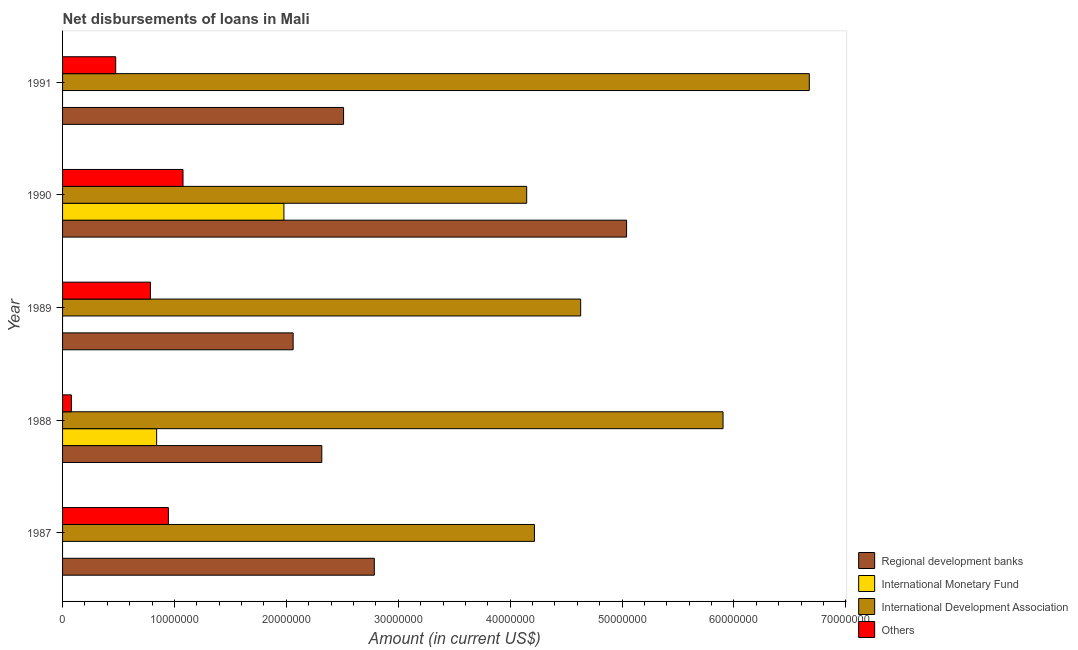Are the number of bars on each tick of the Y-axis equal?
Your response must be concise. No. How many bars are there on the 4th tick from the bottom?
Your answer should be compact. 4. What is the label of the 5th group of bars from the top?
Ensure brevity in your answer.  1987. In how many cases, is the number of bars for a given year not equal to the number of legend labels?
Your answer should be very brief. 3. What is the amount of loan disimbursed by regional development banks in 1991?
Ensure brevity in your answer.  2.51e+07. Across all years, what is the maximum amount of loan disimbursed by regional development banks?
Give a very brief answer. 5.04e+07. Across all years, what is the minimum amount of loan disimbursed by international monetary fund?
Give a very brief answer. 0. What is the total amount of loan disimbursed by international monetary fund in the graph?
Give a very brief answer. 2.82e+07. What is the difference between the amount of loan disimbursed by regional development banks in 1987 and that in 1991?
Your response must be concise. 2.75e+06. What is the difference between the amount of loan disimbursed by international monetary fund in 1989 and the amount of loan disimbursed by international development association in 1991?
Give a very brief answer. -6.67e+07. What is the average amount of loan disimbursed by other organisations per year?
Offer a terse response. 6.72e+06. In the year 1990, what is the difference between the amount of loan disimbursed by other organisations and amount of loan disimbursed by international development association?
Offer a terse response. -3.07e+07. In how many years, is the amount of loan disimbursed by international monetary fund greater than 50000000 US$?
Your answer should be compact. 0. What is the ratio of the amount of loan disimbursed by other organisations in 1988 to that in 1990?
Keep it short and to the point. 0.07. Is the difference between the amount of loan disimbursed by regional development banks in 1987 and 1991 greater than the difference between the amount of loan disimbursed by other organisations in 1987 and 1991?
Ensure brevity in your answer.  No. What is the difference between the highest and the second highest amount of loan disimbursed by regional development banks?
Offer a terse response. 2.25e+07. What is the difference between the highest and the lowest amount of loan disimbursed by other organisations?
Ensure brevity in your answer.  9.98e+06. Is the sum of the amount of loan disimbursed by international monetary fund in 1988 and 1990 greater than the maximum amount of loan disimbursed by other organisations across all years?
Your response must be concise. Yes. Are all the bars in the graph horizontal?
Provide a short and direct response. Yes. Where does the legend appear in the graph?
Offer a very short reply. Bottom right. What is the title of the graph?
Offer a very short reply. Net disbursements of loans in Mali. Does "United States" appear as one of the legend labels in the graph?
Your answer should be compact. No. What is the label or title of the Y-axis?
Offer a terse response. Year. What is the Amount (in current US$) in Regional development banks in 1987?
Ensure brevity in your answer.  2.79e+07. What is the Amount (in current US$) of International Monetary Fund in 1987?
Your response must be concise. 0. What is the Amount (in current US$) in International Development Association in 1987?
Your answer should be very brief. 4.22e+07. What is the Amount (in current US$) of Others in 1987?
Keep it short and to the point. 9.46e+06. What is the Amount (in current US$) of Regional development banks in 1988?
Ensure brevity in your answer.  2.32e+07. What is the Amount (in current US$) in International Monetary Fund in 1988?
Ensure brevity in your answer.  8.41e+06. What is the Amount (in current US$) of International Development Association in 1988?
Your answer should be very brief. 5.90e+07. What is the Amount (in current US$) of Others in 1988?
Your response must be concise. 7.87e+05. What is the Amount (in current US$) of Regional development banks in 1989?
Give a very brief answer. 2.06e+07. What is the Amount (in current US$) in International Development Association in 1989?
Make the answer very short. 4.63e+07. What is the Amount (in current US$) of Others in 1989?
Ensure brevity in your answer.  7.86e+06. What is the Amount (in current US$) in Regional development banks in 1990?
Provide a succinct answer. 5.04e+07. What is the Amount (in current US$) of International Monetary Fund in 1990?
Offer a terse response. 1.98e+07. What is the Amount (in current US$) of International Development Association in 1990?
Provide a short and direct response. 4.15e+07. What is the Amount (in current US$) of Others in 1990?
Provide a succinct answer. 1.08e+07. What is the Amount (in current US$) of Regional development banks in 1991?
Ensure brevity in your answer.  2.51e+07. What is the Amount (in current US$) in International Monetary Fund in 1991?
Offer a very short reply. 0. What is the Amount (in current US$) in International Development Association in 1991?
Offer a very short reply. 6.67e+07. What is the Amount (in current US$) of Others in 1991?
Keep it short and to the point. 4.75e+06. Across all years, what is the maximum Amount (in current US$) of Regional development banks?
Keep it short and to the point. 5.04e+07. Across all years, what is the maximum Amount (in current US$) in International Monetary Fund?
Offer a very short reply. 1.98e+07. Across all years, what is the maximum Amount (in current US$) in International Development Association?
Your response must be concise. 6.67e+07. Across all years, what is the maximum Amount (in current US$) in Others?
Make the answer very short. 1.08e+07. Across all years, what is the minimum Amount (in current US$) of Regional development banks?
Your response must be concise. 2.06e+07. Across all years, what is the minimum Amount (in current US$) in International Monetary Fund?
Give a very brief answer. 0. Across all years, what is the minimum Amount (in current US$) in International Development Association?
Offer a very short reply. 4.15e+07. Across all years, what is the minimum Amount (in current US$) in Others?
Ensure brevity in your answer.  7.87e+05. What is the total Amount (in current US$) in Regional development banks in the graph?
Ensure brevity in your answer.  1.47e+08. What is the total Amount (in current US$) in International Monetary Fund in the graph?
Offer a very short reply. 2.82e+07. What is the total Amount (in current US$) in International Development Association in the graph?
Your answer should be compact. 2.56e+08. What is the total Amount (in current US$) in Others in the graph?
Your answer should be very brief. 3.36e+07. What is the difference between the Amount (in current US$) in Regional development banks in 1987 and that in 1988?
Offer a terse response. 4.69e+06. What is the difference between the Amount (in current US$) in International Development Association in 1987 and that in 1988?
Your answer should be compact. -1.69e+07. What is the difference between the Amount (in current US$) in Others in 1987 and that in 1988?
Ensure brevity in your answer.  8.67e+06. What is the difference between the Amount (in current US$) of Regional development banks in 1987 and that in 1989?
Keep it short and to the point. 7.25e+06. What is the difference between the Amount (in current US$) of International Development Association in 1987 and that in 1989?
Ensure brevity in your answer.  -4.13e+06. What is the difference between the Amount (in current US$) of Others in 1987 and that in 1989?
Provide a succinct answer. 1.60e+06. What is the difference between the Amount (in current US$) of Regional development banks in 1987 and that in 1990?
Keep it short and to the point. -2.25e+07. What is the difference between the Amount (in current US$) in International Development Association in 1987 and that in 1990?
Provide a succinct answer. 6.93e+05. What is the difference between the Amount (in current US$) of Others in 1987 and that in 1990?
Make the answer very short. -1.30e+06. What is the difference between the Amount (in current US$) of Regional development banks in 1987 and that in 1991?
Your response must be concise. 2.75e+06. What is the difference between the Amount (in current US$) of International Development Association in 1987 and that in 1991?
Provide a succinct answer. -2.46e+07. What is the difference between the Amount (in current US$) of Others in 1987 and that in 1991?
Ensure brevity in your answer.  4.71e+06. What is the difference between the Amount (in current US$) in Regional development banks in 1988 and that in 1989?
Offer a terse response. 2.56e+06. What is the difference between the Amount (in current US$) of International Development Association in 1988 and that in 1989?
Your answer should be compact. 1.27e+07. What is the difference between the Amount (in current US$) of Others in 1988 and that in 1989?
Give a very brief answer. -7.07e+06. What is the difference between the Amount (in current US$) in Regional development banks in 1988 and that in 1990?
Make the answer very short. -2.72e+07. What is the difference between the Amount (in current US$) in International Monetary Fund in 1988 and that in 1990?
Offer a terse response. -1.14e+07. What is the difference between the Amount (in current US$) in International Development Association in 1988 and that in 1990?
Provide a short and direct response. 1.75e+07. What is the difference between the Amount (in current US$) in Others in 1988 and that in 1990?
Provide a short and direct response. -9.98e+06. What is the difference between the Amount (in current US$) of Regional development banks in 1988 and that in 1991?
Keep it short and to the point. -1.95e+06. What is the difference between the Amount (in current US$) in International Development Association in 1988 and that in 1991?
Ensure brevity in your answer.  -7.71e+06. What is the difference between the Amount (in current US$) in Others in 1988 and that in 1991?
Offer a terse response. -3.96e+06. What is the difference between the Amount (in current US$) in Regional development banks in 1989 and that in 1990?
Your answer should be compact. -2.98e+07. What is the difference between the Amount (in current US$) of International Development Association in 1989 and that in 1990?
Your response must be concise. 4.82e+06. What is the difference between the Amount (in current US$) of Others in 1989 and that in 1990?
Your answer should be very brief. -2.91e+06. What is the difference between the Amount (in current US$) of Regional development banks in 1989 and that in 1991?
Your response must be concise. -4.51e+06. What is the difference between the Amount (in current US$) in International Development Association in 1989 and that in 1991?
Your answer should be very brief. -2.04e+07. What is the difference between the Amount (in current US$) of Others in 1989 and that in 1991?
Offer a very short reply. 3.11e+06. What is the difference between the Amount (in current US$) of Regional development banks in 1990 and that in 1991?
Give a very brief answer. 2.53e+07. What is the difference between the Amount (in current US$) in International Development Association in 1990 and that in 1991?
Offer a very short reply. -2.53e+07. What is the difference between the Amount (in current US$) of Others in 1990 and that in 1991?
Keep it short and to the point. 6.02e+06. What is the difference between the Amount (in current US$) of Regional development banks in 1987 and the Amount (in current US$) of International Monetary Fund in 1988?
Offer a very short reply. 1.95e+07. What is the difference between the Amount (in current US$) in Regional development banks in 1987 and the Amount (in current US$) in International Development Association in 1988?
Ensure brevity in your answer.  -3.12e+07. What is the difference between the Amount (in current US$) in Regional development banks in 1987 and the Amount (in current US$) in Others in 1988?
Your response must be concise. 2.71e+07. What is the difference between the Amount (in current US$) of International Development Association in 1987 and the Amount (in current US$) of Others in 1988?
Your answer should be compact. 4.14e+07. What is the difference between the Amount (in current US$) of Regional development banks in 1987 and the Amount (in current US$) of International Development Association in 1989?
Keep it short and to the point. -1.84e+07. What is the difference between the Amount (in current US$) of Regional development banks in 1987 and the Amount (in current US$) of Others in 1989?
Provide a short and direct response. 2.00e+07. What is the difference between the Amount (in current US$) in International Development Association in 1987 and the Amount (in current US$) in Others in 1989?
Provide a short and direct response. 3.43e+07. What is the difference between the Amount (in current US$) in Regional development banks in 1987 and the Amount (in current US$) in International Monetary Fund in 1990?
Provide a short and direct response. 8.08e+06. What is the difference between the Amount (in current US$) of Regional development banks in 1987 and the Amount (in current US$) of International Development Association in 1990?
Keep it short and to the point. -1.36e+07. What is the difference between the Amount (in current US$) in Regional development banks in 1987 and the Amount (in current US$) in Others in 1990?
Offer a very short reply. 1.71e+07. What is the difference between the Amount (in current US$) of International Development Association in 1987 and the Amount (in current US$) of Others in 1990?
Make the answer very short. 3.14e+07. What is the difference between the Amount (in current US$) of Regional development banks in 1987 and the Amount (in current US$) of International Development Association in 1991?
Make the answer very short. -3.89e+07. What is the difference between the Amount (in current US$) of Regional development banks in 1987 and the Amount (in current US$) of Others in 1991?
Make the answer very short. 2.31e+07. What is the difference between the Amount (in current US$) of International Development Association in 1987 and the Amount (in current US$) of Others in 1991?
Ensure brevity in your answer.  3.74e+07. What is the difference between the Amount (in current US$) in Regional development banks in 1988 and the Amount (in current US$) in International Development Association in 1989?
Offer a terse response. -2.31e+07. What is the difference between the Amount (in current US$) in Regional development banks in 1988 and the Amount (in current US$) in Others in 1989?
Your answer should be compact. 1.53e+07. What is the difference between the Amount (in current US$) in International Monetary Fund in 1988 and the Amount (in current US$) in International Development Association in 1989?
Offer a very short reply. -3.79e+07. What is the difference between the Amount (in current US$) in International Monetary Fund in 1988 and the Amount (in current US$) in Others in 1989?
Ensure brevity in your answer.  5.53e+05. What is the difference between the Amount (in current US$) of International Development Association in 1988 and the Amount (in current US$) of Others in 1989?
Your answer should be very brief. 5.12e+07. What is the difference between the Amount (in current US$) in Regional development banks in 1988 and the Amount (in current US$) in International Monetary Fund in 1990?
Offer a very short reply. 3.39e+06. What is the difference between the Amount (in current US$) in Regional development banks in 1988 and the Amount (in current US$) in International Development Association in 1990?
Keep it short and to the point. -1.83e+07. What is the difference between the Amount (in current US$) in Regional development banks in 1988 and the Amount (in current US$) in Others in 1990?
Offer a terse response. 1.24e+07. What is the difference between the Amount (in current US$) in International Monetary Fund in 1988 and the Amount (in current US$) in International Development Association in 1990?
Give a very brief answer. -3.31e+07. What is the difference between the Amount (in current US$) in International Monetary Fund in 1988 and the Amount (in current US$) in Others in 1990?
Give a very brief answer. -2.36e+06. What is the difference between the Amount (in current US$) in International Development Association in 1988 and the Amount (in current US$) in Others in 1990?
Ensure brevity in your answer.  4.83e+07. What is the difference between the Amount (in current US$) of Regional development banks in 1988 and the Amount (in current US$) of International Development Association in 1991?
Your answer should be very brief. -4.36e+07. What is the difference between the Amount (in current US$) of Regional development banks in 1988 and the Amount (in current US$) of Others in 1991?
Your answer should be compact. 1.84e+07. What is the difference between the Amount (in current US$) in International Monetary Fund in 1988 and the Amount (in current US$) in International Development Association in 1991?
Provide a short and direct response. -5.83e+07. What is the difference between the Amount (in current US$) of International Monetary Fund in 1988 and the Amount (in current US$) of Others in 1991?
Make the answer very short. 3.66e+06. What is the difference between the Amount (in current US$) of International Development Association in 1988 and the Amount (in current US$) of Others in 1991?
Provide a succinct answer. 5.43e+07. What is the difference between the Amount (in current US$) of Regional development banks in 1989 and the Amount (in current US$) of International Monetary Fund in 1990?
Your answer should be very brief. 8.24e+05. What is the difference between the Amount (in current US$) of Regional development banks in 1989 and the Amount (in current US$) of International Development Association in 1990?
Offer a very short reply. -2.09e+07. What is the difference between the Amount (in current US$) in Regional development banks in 1989 and the Amount (in current US$) in Others in 1990?
Your answer should be compact. 9.84e+06. What is the difference between the Amount (in current US$) of International Development Association in 1989 and the Amount (in current US$) of Others in 1990?
Your response must be concise. 3.55e+07. What is the difference between the Amount (in current US$) of Regional development banks in 1989 and the Amount (in current US$) of International Development Association in 1991?
Make the answer very short. -4.61e+07. What is the difference between the Amount (in current US$) in Regional development banks in 1989 and the Amount (in current US$) in Others in 1991?
Provide a short and direct response. 1.59e+07. What is the difference between the Amount (in current US$) of International Development Association in 1989 and the Amount (in current US$) of Others in 1991?
Ensure brevity in your answer.  4.16e+07. What is the difference between the Amount (in current US$) of Regional development banks in 1990 and the Amount (in current US$) of International Development Association in 1991?
Your answer should be compact. -1.63e+07. What is the difference between the Amount (in current US$) in Regional development banks in 1990 and the Amount (in current US$) in Others in 1991?
Keep it short and to the point. 4.57e+07. What is the difference between the Amount (in current US$) of International Monetary Fund in 1990 and the Amount (in current US$) of International Development Association in 1991?
Make the answer very short. -4.70e+07. What is the difference between the Amount (in current US$) of International Monetary Fund in 1990 and the Amount (in current US$) of Others in 1991?
Your answer should be compact. 1.50e+07. What is the difference between the Amount (in current US$) of International Development Association in 1990 and the Amount (in current US$) of Others in 1991?
Provide a short and direct response. 3.67e+07. What is the average Amount (in current US$) in Regional development banks per year?
Ensure brevity in your answer.  2.94e+07. What is the average Amount (in current US$) of International Monetary Fund per year?
Make the answer very short. 5.64e+06. What is the average Amount (in current US$) of International Development Association per year?
Provide a short and direct response. 5.11e+07. What is the average Amount (in current US$) of Others per year?
Ensure brevity in your answer.  6.72e+06. In the year 1987, what is the difference between the Amount (in current US$) in Regional development banks and Amount (in current US$) in International Development Association?
Offer a very short reply. -1.43e+07. In the year 1987, what is the difference between the Amount (in current US$) in Regional development banks and Amount (in current US$) in Others?
Make the answer very short. 1.84e+07. In the year 1987, what is the difference between the Amount (in current US$) of International Development Association and Amount (in current US$) of Others?
Your answer should be compact. 3.27e+07. In the year 1988, what is the difference between the Amount (in current US$) of Regional development banks and Amount (in current US$) of International Monetary Fund?
Make the answer very short. 1.48e+07. In the year 1988, what is the difference between the Amount (in current US$) of Regional development banks and Amount (in current US$) of International Development Association?
Provide a succinct answer. -3.59e+07. In the year 1988, what is the difference between the Amount (in current US$) of Regional development banks and Amount (in current US$) of Others?
Make the answer very short. 2.24e+07. In the year 1988, what is the difference between the Amount (in current US$) of International Monetary Fund and Amount (in current US$) of International Development Association?
Provide a succinct answer. -5.06e+07. In the year 1988, what is the difference between the Amount (in current US$) of International Monetary Fund and Amount (in current US$) of Others?
Your response must be concise. 7.62e+06. In the year 1988, what is the difference between the Amount (in current US$) in International Development Association and Amount (in current US$) in Others?
Your answer should be compact. 5.82e+07. In the year 1989, what is the difference between the Amount (in current US$) in Regional development banks and Amount (in current US$) in International Development Association?
Give a very brief answer. -2.57e+07. In the year 1989, what is the difference between the Amount (in current US$) in Regional development banks and Amount (in current US$) in Others?
Your answer should be very brief. 1.28e+07. In the year 1989, what is the difference between the Amount (in current US$) of International Development Association and Amount (in current US$) of Others?
Your answer should be very brief. 3.84e+07. In the year 1990, what is the difference between the Amount (in current US$) in Regional development banks and Amount (in current US$) in International Monetary Fund?
Your answer should be compact. 3.06e+07. In the year 1990, what is the difference between the Amount (in current US$) in Regional development banks and Amount (in current US$) in International Development Association?
Ensure brevity in your answer.  8.93e+06. In the year 1990, what is the difference between the Amount (in current US$) in Regional development banks and Amount (in current US$) in Others?
Keep it short and to the point. 3.96e+07. In the year 1990, what is the difference between the Amount (in current US$) of International Monetary Fund and Amount (in current US$) of International Development Association?
Your answer should be very brief. -2.17e+07. In the year 1990, what is the difference between the Amount (in current US$) of International Monetary Fund and Amount (in current US$) of Others?
Your answer should be compact. 9.02e+06. In the year 1990, what is the difference between the Amount (in current US$) in International Development Association and Amount (in current US$) in Others?
Offer a very short reply. 3.07e+07. In the year 1991, what is the difference between the Amount (in current US$) in Regional development banks and Amount (in current US$) in International Development Association?
Your response must be concise. -4.16e+07. In the year 1991, what is the difference between the Amount (in current US$) in Regional development banks and Amount (in current US$) in Others?
Ensure brevity in your answer.  2.04e+07. In the year 1991, what is the difference between the Amount (in current US$) of International Development Association and Amount (in current US$) of Others?
Your response must be concise. 6.20e+07. What is the ratio of the Amount (in current US$) of Regional development banks in 1987 to that in 1988?
Provide a short and direct response. 1.2. What is the ratio of the Amount (in current US$) of International Development Association in 1987 to that in 1988?
Provide a short and direct response. 0.71. What is the ratio of the Amount (in current US$) in Others in 1987 to that in 1988?
Give a very brief answer. 12.02. What is the ratio of the Amount (in current US$) of Regional development banks in 1987 to that in 1989?
Ensure brevity in your answer.  1.35. What is the ratio of the Amount (in current US$) in International Development Association in 1987 to that in 1989?
Your answer should be very brief. 0.91. What is the ratio of the Amount (in current US$) of Others in 1987 to that in 1989?
Your answer should be very brief. 1.2. What is the ratio of the Amount (in current US$) of Regional development banks in 1987 to that in 1990?
Ensure brevity in your answer.  0.55. What is the ratio of the Amount (in current US$) in International Development Association in 1987 to that in 1990?
Give a very brief answer. 1.02. What is the ratio of the Amount (in current US$) in Others in 1987 to that in 1990?
Offer a very short reply. 0.88. What is the ratio of the Amount (in current US$) of Regional development banks in 1987 to that in 1991?
Your response must be concise. 1.11. What is the ratio of the Amount (in current US$) in International Development Association in 1987 to that in 1991?
Give a very brief answer. 0.63. What is the ratio of the Amount (in current US$) in Others in 1987 to that in 1991?
Provide a short and direct response. 1.99. What is the ratio of the Amount (in current US$) in Regional development banks in 1988 to that in 1989?
Your answer should be compact. 1.12. What is the ratio of the Amount (in current US$) of International Development Association in 1988 to that in 1989?
Offer a terse response. 1.27. What is the ratio of the Amount (in current US$) of Others in 1988 to that in 1989?
Your answer should be very brief. 0.1. What is the ratio of the Amount (in current US$) of Regional development banks in 1988 to that in 1990?
Offer a very short reply. 0.46. What is the ratio of the Amount (in current US$) of International Monetary Fund in 1988 to that in 1990?
Provide a short and direct response. 0.42. What is the ratio of the Amount (in current US$) of International Development Association in 1988 to that in 1990?
Ensure brevity in your answer.  1.42. What is the ratio of the Amount (in current US$) in Others in 1988 to that in 1990?
Make the answer very short. 0.07. What is the ratio of the Amount (in current US$) of Regional development banks in 1988 to that in 1991?
Your answer should be compact. 0.92. What is the ratio of the Amount (in current US$) in International Development Association in 1988 to that in 1991?
Offer a very short reply. 0.88. What is the ratio of the Amount (in current US$) in Others in 1988 to that in 1991?
Provide a short and direct response. 0.17. What is the ratio of the Amount (in current US$) in Regional development banks in 1989 to that in 1990?
Ensure brevity in your answer.  0.41. What is the ratio of the Amount (in current US$) of International Development Association in 1989 to that in 1990?
Offer a terse response. 1.12. What is the ratio of the Amount (in current US$) of Others in 1989 to that in 1990?
Provide a short and direct response. 0.73. What is the ratio of the Amount (in current US$) of Regional development banks in 1989 to that in 1991?
Make the answer very short. 0.82. What is the ratio of the Amount (in current US$) of International Development Association in 1989 to that in 1991?
Ensure brevity in your answer.  0.69. What is the ratio of the Amount (in current US$) of Others in 1989 to that in 1991?
Keep it short and to the point. 1.65. What is the ratio of the Amount (in current US$) of Regional development banks in 1990 to that in 1991?
Offer a terse response. 2.01. What is the ratio of the Amount (in current US$) of International Development Association in 1990 to that in 1991?
Ensure brevity in your answer.  0.62. What is the ratio of the Amount (in current US$) in Others in 1990 to that in 1991?
Keep it short and to the point. 2.27. What is the difference between the highest and the second highest Amount (in current US$) of Regional development banks?
Give a very brief answer. 2.25e+07. What is the difference between the highest and the second highest Amount (in current US$) of International Development Association?
Your answer should be compact. 7.71e+06. What is the difference between the highest and the second highest Amount (in current US$) in Others?
Your response must be concise. 1.30e+06. What is the difference between the highest and the lowest Amount (in current US$) of Regional development banks?
Ensure brevity in your answer.  2.98e+07. What is the difference between the highest and the lowest Amount (in current US$) in International Monetary Fund?
Your response must be concise. 1.98e+07. What is the difference between the highest and the lowest Amount (in current US$) in International Development Association?
Your answer should be compact. 2.53e+07. What is the difference between the highest and the lowest Amount (in current US$) in Others?
Ensure brevity in your answer.  9.98e+06. 